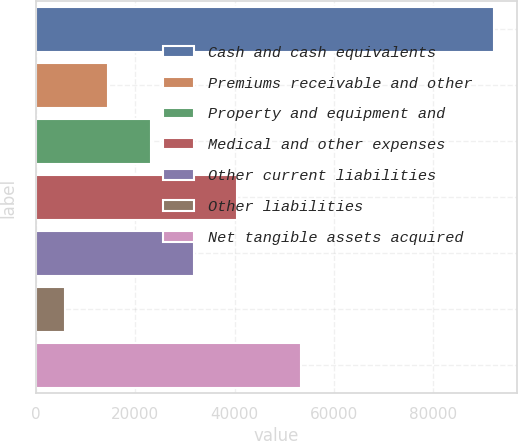<chart> <loc_0><loc_0><loc_500><loc_500><bar_chart><fcel>Cash and cash equivalents<fcel>Premiums receivable and other<fcel>Property and equipment and<fcel>Medical and other expenses<fcel>Other current liabilities<fcel>Other liabilities<fcel>Net tangible assets acquired<nl><fcel>92116<fcel>14535.1<fcel>23155.2<fcel>40395.4<fcel>31775.3<fcel>5915<fcel>53292<nl></chart> 